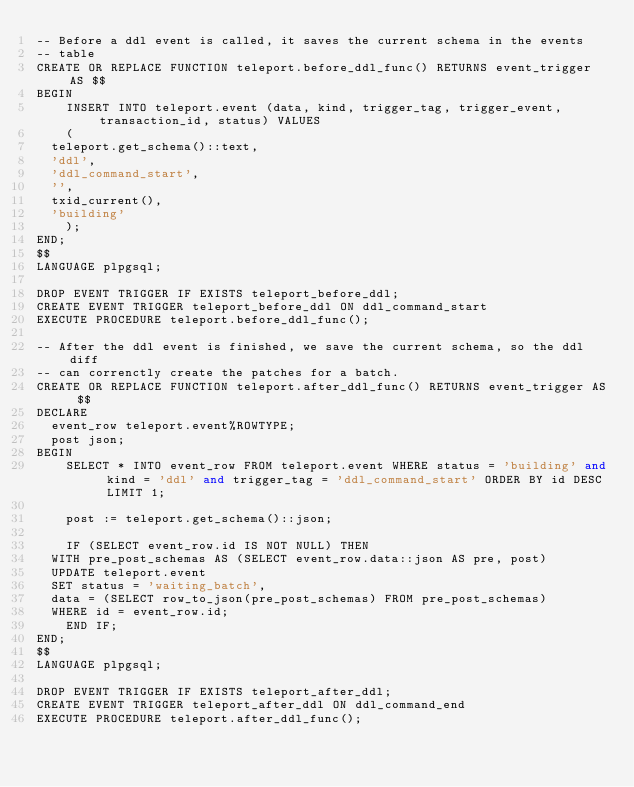Convert code to text. <code><loc_0><loc_0><loc_500><loc_500><_SQL_>-- Before a ddl event is called, it saves the current schema in the events
-- table
CREATE OR REPLACE FUNCTION teleport.before_ddl_func() RETURNS event_trigger AS $$
BEGIN
    INSERT INTO teleport.event (data, kind, trigger_tag, trigger_event, transaction_id, status) VALUES
    (
	teleport.get_schema()::text,
	'ddl',
	'ddl_command_start',
	'',
	txid_current(),
	'building'
    );
END;
$$
LANGUAGE plpgsql;

DROP EVENT TRIGGER IF EXISTS teleport_before_ddl;
CREATE EVENT TRIGGER teleport_before_ddl ON ddl_command_start
EXECUTE PROCEDURE teleport.before_ddl_func();

-- After the ddl event is finished, we save the current schema, so the ddl diff
-- can correnctly create the patches for a batch.
CREATE OR REPLACE FUNCTION teleport.after_ddl_func() RETURNS event_trigger AS $$
DECLARE
	event_row teleport.event%ROWTYPE;
	post json;
BEGIN
    SELECT * INTO event_row FROM teleport.event WHERE status = 'building' and kind = 'ddl' and trigger_tag = 'ddl_command_start' ORDER BY id DESC LIMIT 1;

    post := teleport.get_schema()::json;

    IF (SELECT event_row.id IS NOT NULL) THEN
	WITH pre_post_schemas AS (SELECT event_row.data::json AS pre, post)
	UPDATE teleport.event
	SET status = 'waiting_batch',
	data = (SELECT row_to_json(pre_post_schemas) FROM pre_post_schemas)
	WHERE id = event_row.id;
    END IF;
END;
$$
LANGUAGE plpgsql;

DROP EVENT TRIGGER IF EXISTS teleport_after_ddl;
CREATE EVENT TRIGGER teleport_after_ddl ON ddl_command_end
EXECUTE PROCEDURE teleport.after_ddl_func();


</code> 